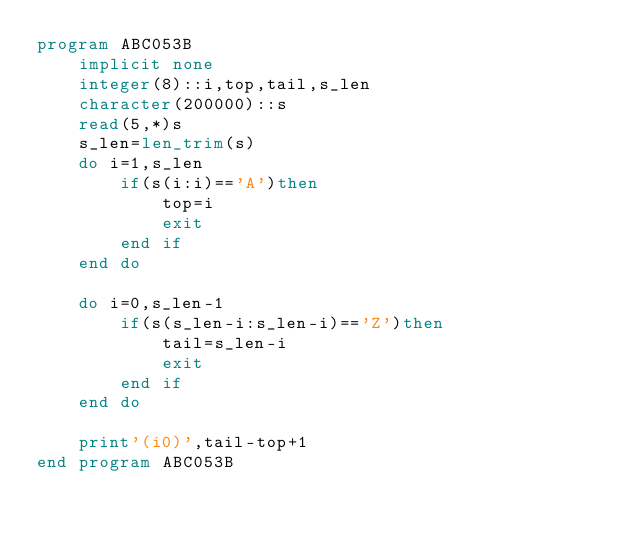<code> <loc_0><loc_0><loc_500><loc_500><_FORTRAN_>program ABC053B
    implicit none
    integer(8)::i,top,tail,s_len
    character(200000)::s
    read(5,*)s
    s_len=len_trim(s)
    do i=1,s_len
        if(s(i:i)=='A')then
            top=i
            exit
        end if
    end do

    do i=0,s_len-1
        if(s(s_len-i:s_len-i)=='Z')then
            tail=s_len-i
            exit
        end if
    end do

    print'(i0)',tail-top+1
end program ABC053B</code> 